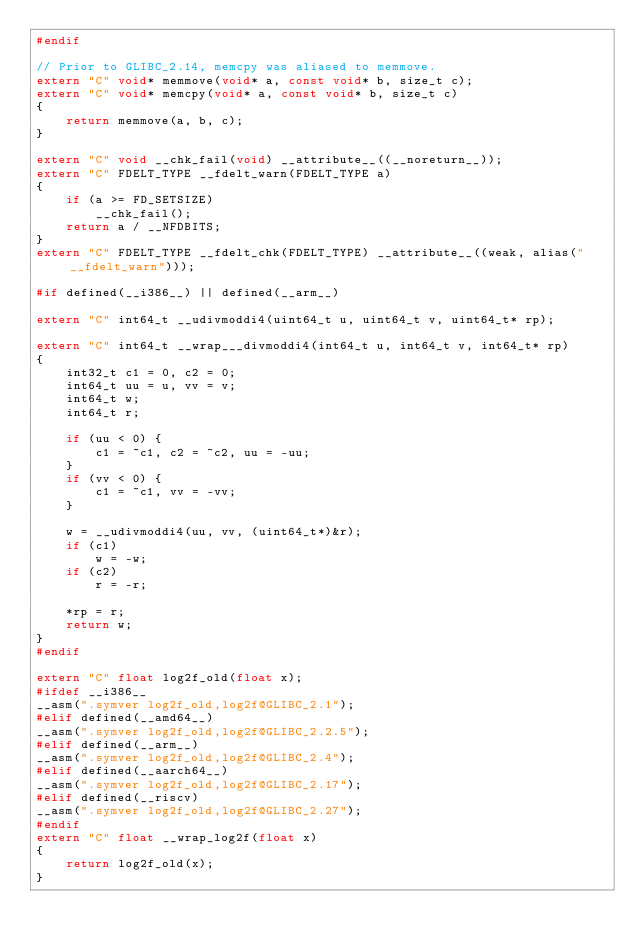Convert code to text. <code><loc_0><loc_0><loc_500><loc_500><_C++_>#endif

// Prior to GLIBC_2.14, memcpy was aliased to memmove.
extern "C" void* memmove(void* a, const void* b, size_t c);
extern "C" void* memcpy(void* a, const void* b, size_t c)
{
    return memmove(a, b, c);
}

extern "C" void __chk_fail(void) __attribute__((__noreturn__));
extern "C" FDELT_TYPE __fdelt_warn(FDELT_TYPE a)
{
    if (a >= FD_SETSIZE)
        __chk_fail();
    return a / __NFDBITS;
}
extern "C" FDELT_TYPE __fdelt_chk(FDELT_TYPE) __attribute__((weak, alias("__fdelt_warn")));

#if defined(__i386__) || defined(__arm__)

extern "C" int64_t __udivmoddi4(uint64_t u, uint64_t v, uint64_t* rp);

extern "C" int64_t __wrap___divmoddi4(int64_t u, int64_t v, int64_t* rp)
{
    int32_t c1 = 0, c2 = 0;
    int64_t uu = u, vv = v;
    int64_t w;
    int64_t r;

    if (uu < 0) {
        c1 = ~c1, c2 = ~c2, uu = -uu;
    }
    if (vv < 0) {
        c1 = ~c1, vv = -vv;
    }

    w = __udivmoddi4(uu, vv, (uint64_t*)&r);
    if (c1)
        w = -w;
    if (c2)
        r = -r;

    *rp = r;
    return w;
}
#endif

extern "C" float log2f_old(float x);
#ifdef __i386__
__asm(".symver log2f_old,log2f@GLIBC_2.1");
#elif defined(__amd64__)
__asm(".symver log2f_old,log2f@GLIBC_2.2.5");
#elif defined(__arm__)
__asm(".symver log2f_old,log2f@GLIBC_2.4");
#elif defined(__aarch64__)
__asm(".symver log2f_old,log2f@GLIBC_2.17");
#elif defined(__riscv)
__asm(".symver log2f_old,log2f@GLIBC_2.27");
#endif
extern "C" float __wrap_log2f(float x)
{
    return log2f_old(x);
}
</code> 